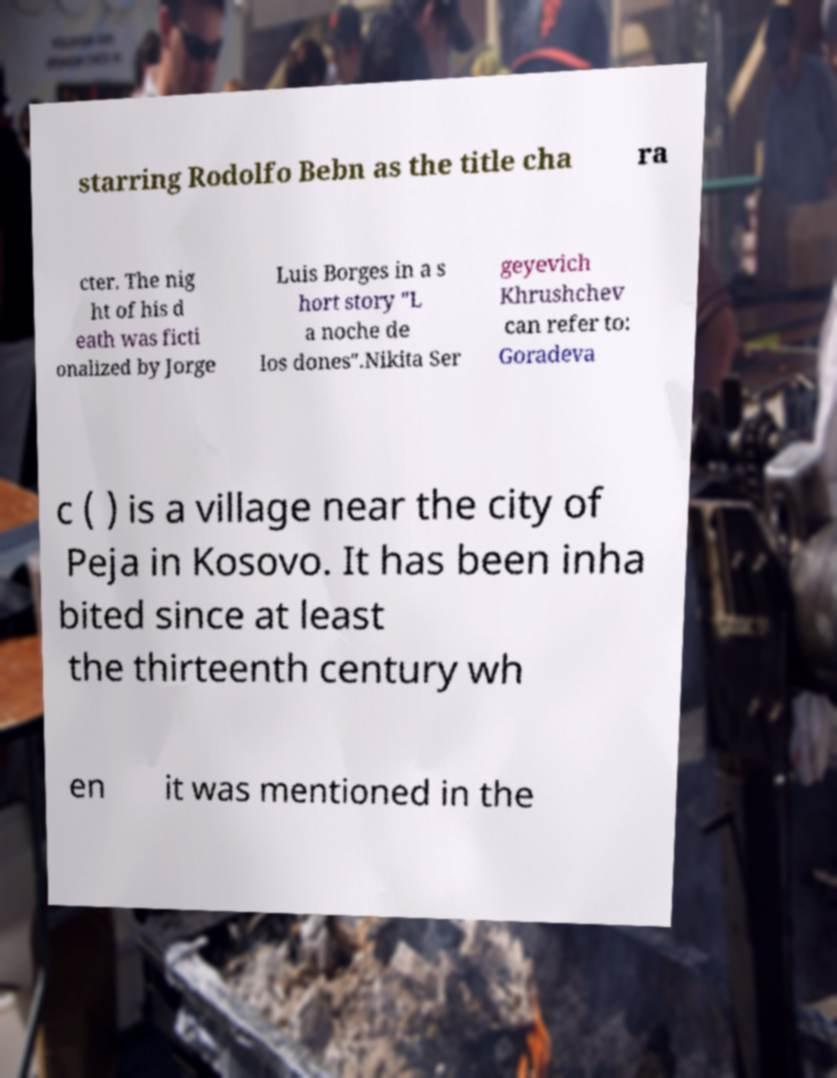I need the written content from this picture converted into text. Can you do that? starring Rodolfo Bebn as the title cha ra cter. The nig ht of his d eath was ficti onalized by Jorge Luis Borges in a s hort story "L a noche de los dones".Nikita Ser geyevich Khrushchev can refer to: Goradeva c ( ) is a village near the city of Peja in Kosovo. It has been inha bited since at least the thirteenth century wh en it was mentioned in the 